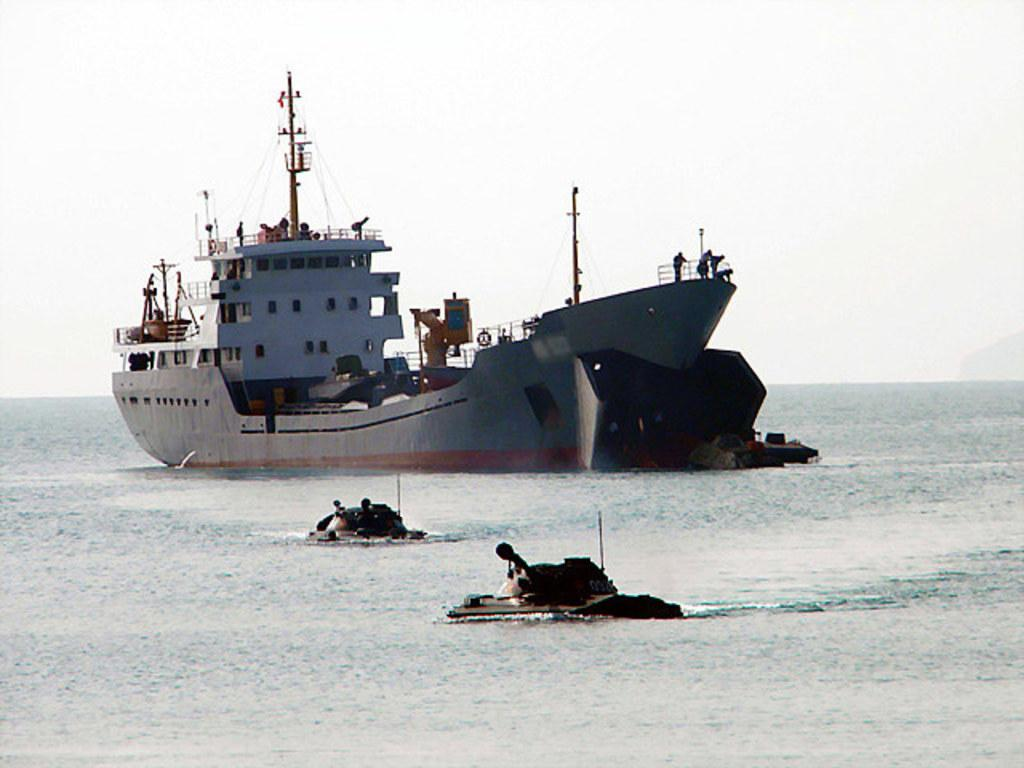What is the main subject in the water in the image? There is a big ship in the water. What is unique about this ship? There is a building on the ship. What else can be seen on the ship? There are poles on the ship. What is visible at the top of the image? The sky is visible at the top of the image. What else is in the water near the ship? There are two small boats in the water. What letters are visible on the side of the ship? There are no letters visible on the side of the ship in the image. What type of vacation is being taken on the ship? The image does not provide any information about a vacation or the purpose of the ship. 